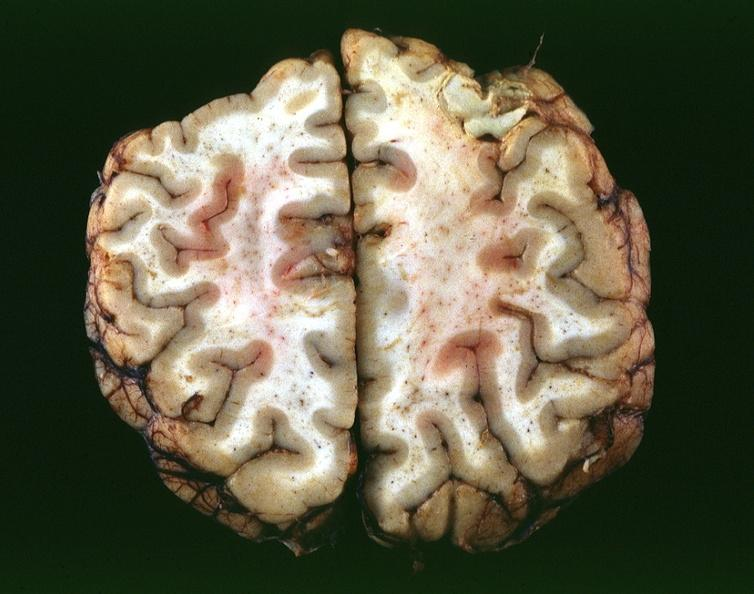what does this image show?
Answer the question using a single word or phrase. Toxoplasmosis 